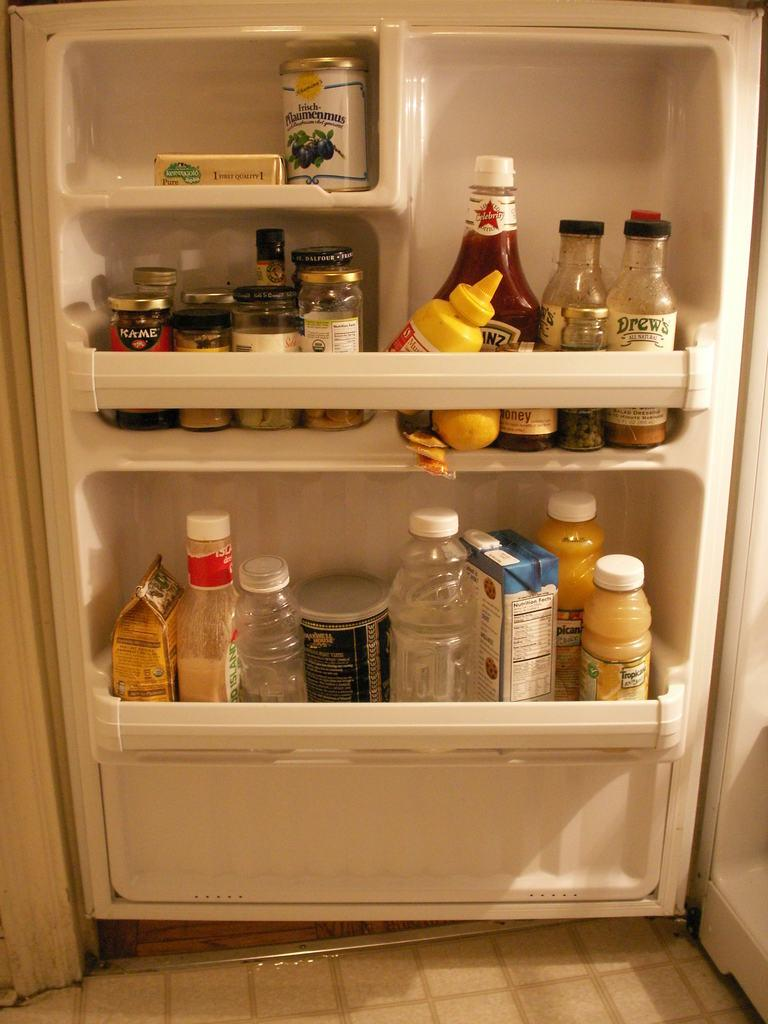What type of containers are visible in the image? There are squeeze bottles, jars, packets, and cans in the image. Where are these containers located? The objects are located in a freeze door. What type of room might the image be taken in? The image is likely taken in a room, possibly a kitchen or storage area. What type of trees can be seen in the image? There are no trees present in the image; it features containers in a freeze door. What type of minister is depicted in the image? There is no minister depicted in the image; it only shows containers in a freeze door. 